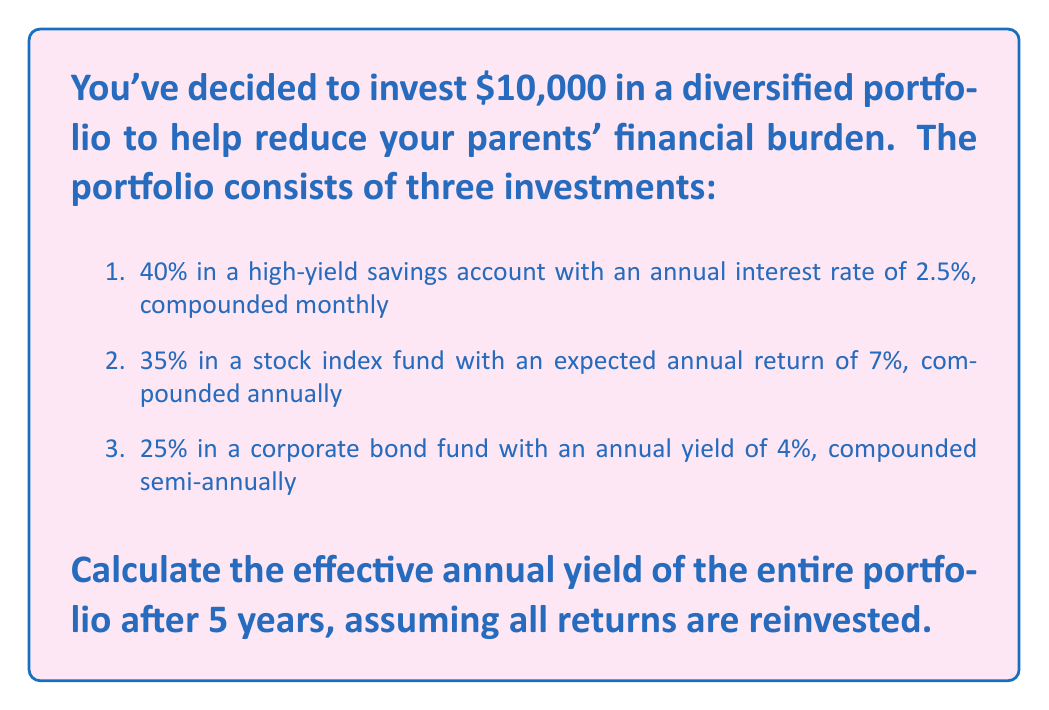Teach me how to tackle this problem. To solve this problem, we need to calculate the future value of each investment after 5 years and then determine the effective annual yield of the entire portfolio.

Step 1: Calculate the future value of each investment

1. High-yield savings account (40% of $10,000 = $4,000)
   Using the compound interest formula: $A = P(1 + \frac{r}{n})^{nt}$
   Where A is the future value, P is the principal, r is the annual interest rate, n is the number of times compounded per year, and t is the time in years.

   $A_1 = 4000(1 + \frac{0.025}{12})^{12 * 5} = $4,530.73$

2. Stock index fund (35% of $10,000 = $3,500)
   $A_2 = 3500(1 + 0.07)^5 = $4,908.85$

3. Corporate bond fund (25% of $10,000 = $2,500)
   $A_3 = 2500(1 + \frac{0.04}{2})^{2 * 5} = $3,041.22$

Step 2: Calculate the total future value of the portfolio
Total future value = $4,530.73 + $4,908.85 + $3,041.22 = $12,480.80

Step 3: Calculate the effective annual yield
To find the effective annual yield, we use the formula:
$$(1 + r)^t = \frac{A}{P}$$

Where r is the effective annual yield, t is the time in years, A is the future value, and P is the initial investment.

$$(1 + r)^5 = \frac{12480.80}{10000}$$
$$(1 + r)^5 = 1.24808$$
$$1 + r = 1.24808^{\frac{1}{5}}$$
$$r = 1.24808^{\frac{1}{5}} - 1 = 0.04528$$

Therefore, the effective annual yield is 4.528% or approximately 4.53%.
Answer: 4.53% 